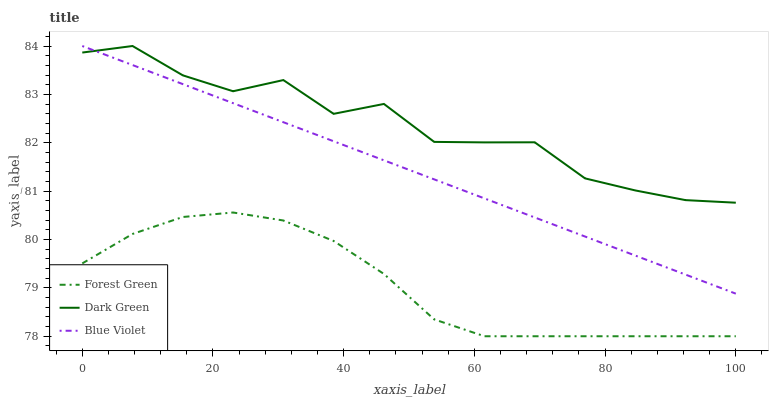Does Forest Green have the minimum area under the curve?
Answer yes or no. Yes. Does Dark Green have the maximum area under the curve?
Answer yes or no. Yes. Does Blue Violet have the minimum area under the curve?
Answer yes or no. No. Does Blue Violet have the maximum area under the curve?
Answer yes or no. No. Is Blue Violet the smoothest?
Answer yes or no. Yes. Is Dark Green the roughest?
Answer yes or no. Yes. Is Dark Green the smoothest?
Answer yes or no. No. Is Blue Violet the roughest?
Answer yes or no. No. Does Forest Green have the lowest value?
Answer yes or no. Yes. Does Blue Violet have the lowest value?
Answer yes or no. No. Does Dark Green have the highest value?
Answer yes or no. Yes. Is Forest Green less than Blue Violet?
Answer yes or no. Yes. Is Blue Violet greater than Forest Green?
Answer yes or no. Yes. Does Dark Green intersect Blue Violet?
Answer yes or no. Yes. Is Dark Green less than Blue Violet?
Answer yes or no. No. Is Dark Green greater than Blue Violet?
Answer yes or no. No. Does Forest Green intersect Blue Violet?
Answer yes or no. No. 